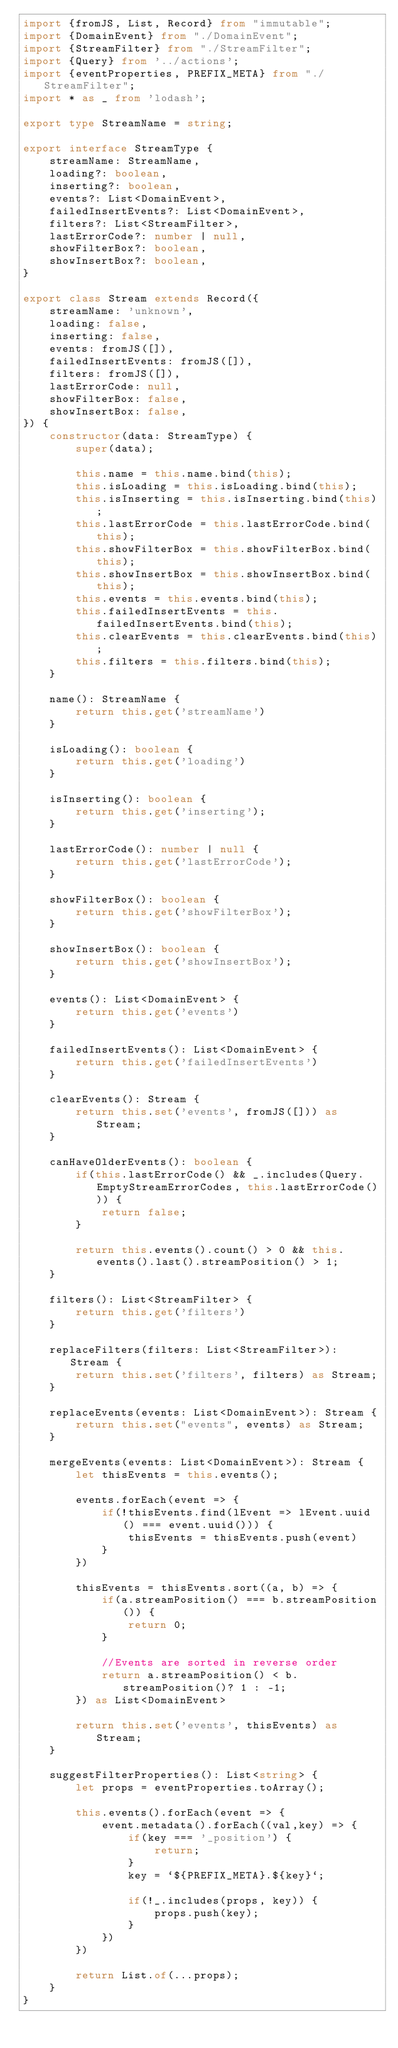<code> <loc_0><loc_0><loc_500><loc_500><_TypeScript_>import {fromJS, List, Record} from "immutable";
import {DomainEvent} from "./DomainEvent";
import {StreamFilter} from "./StreamFilter";
import {Query} from '../actions';
import {eventProperties, PREFIX_META} from "./StreamFilter";
import * as _ from 'lodash';

export type StreamName = string;

export interface StreamType {
    streamName: StreamName,
    loading?: boolean,
    inserting?: boolean,
    events?: List<DomainEvent>,
    failedInsertEvents?: List<DomainEvent>,
    filters?: List<StreamFilter>,
    lastErrorCode?: number | null,
    showFilterBox?: boolean,
    showInsertBox?: boolean,
}

export class Stream extends Record({
    streamName: 'unknown',
    loading: false,
    inserting: false,
    events: fromJS([]),
    failedInsertEvents: fromJS([]),
    filters: fromJS([]),
    lastErrorCode: null,
    showFilterBox: false,
    showInsertBox: false,
}) {
    constructor(data: StreamType) {
        super(data);

        this.name = this.name.bind(this);
        this.isLoading = this.isLoading.bind(this);
        this.isInserting = this.isInserting.bind(this);
        this.lastErrorCode = this.lastErrorCode.bind(this);
        this.showFilterBox = this.showFilterBox.bind(this);
        this.showInsertBox = this.showInsertBox.bind(this);
        this.events = this.events.bind(this);
        this.failedInsertEvents = this.failedInsertEvents.bind(this);
        this.clearEvents = this.clearEvents.bind(this);
        this.filters = this.filters.bind(this);
    }

    name(): StreamName {
        return this.get('streamName')
    }

    isLoading(): boolean {
        return this.get('loading')
    }

    isInserting(): boolean {
        return this.get('inserting');
    }

    lastErrorCode(): number | null {
        return this.get('lastErrorCode');
    }

    showFilterBox(): boolean {
        return this.get('showFilterBox');
    }

    showInsertBox(): boolean {
        return this.get('showInsertBox');
    }

    events(): List<DomainEvent> {
        return this.get('events')
    }

    failedInsertEvents(): List<DomainEvent> {
        return this.get('failedInsertEvents')
    }

    clearEvents(): Stream {
        return this.set('events', fromJS([])) as Stream;
    }

    canHaveOlderEvents(): boolean {
        if(this.lastErrorCode() && _.includes(Query.EmptyStreamErrorCodes, this.lastErrorCode())) {
            return false;
        }

        return this.events().count() > 0 && this.events().last().streamPosition() > 1;
    }

    filters(): List<StreamFilter> {
        return this.get('filters')
    }

    replaceFilters(filters: List<StreamFilter>): Stream {
        return this.set('filters', filters) as Stream;
    }

    replaceEvents(events: List<DomainEvent>): Stream {
        return this.set("events", events) as Stream;
    }

    mergeEvents(events: List<DomainEvent>): Stream {
        let thisEvents = this.events();

        events.forEach(event => {
            if(!thisEvents.find(lEvent => lEvent.uuid() === event.uuid())) {
                thisEvents = thisEvents.push(event)
            }
        })

        thisEvents = thisEvents.sort((a, b) => {
            if(a.streamPosition() === b.streamPosition()) {
                return 0;
            }

            //Events are sorted in reverse order
            return a.streamPosition() < b.streamPosition()? 1 : -1;
        }) as List<DomainEvent>

        return this.set('events', thisEvents) as Stream;
    }

    suggestFilterProperties(): List<string> {
        let props = eventProperties.toArray();

        this.events().forEach(event => {
            event.metadata().forEach((val,key) => {
                if(key === '_position') {
                    return;
                }
                key = `${PREFIX_META}.${key}`;

                if(!_.includes(props, key)) {
                    props.push(key);
                }
            })
        })

        return List.of(...props);
    }
}
</code> 